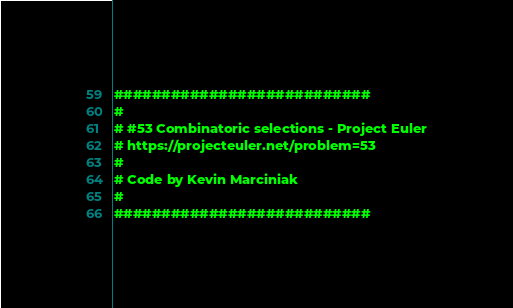<code> <loc_0><loc_0><loc_500><loc_500><_Python_>###########################
#
# #53 Combinatoric selections - Project Euler
# https://projecteuler.net/problem=53
#
# Code by Kevin Marciniak
#
###########################
</code> 